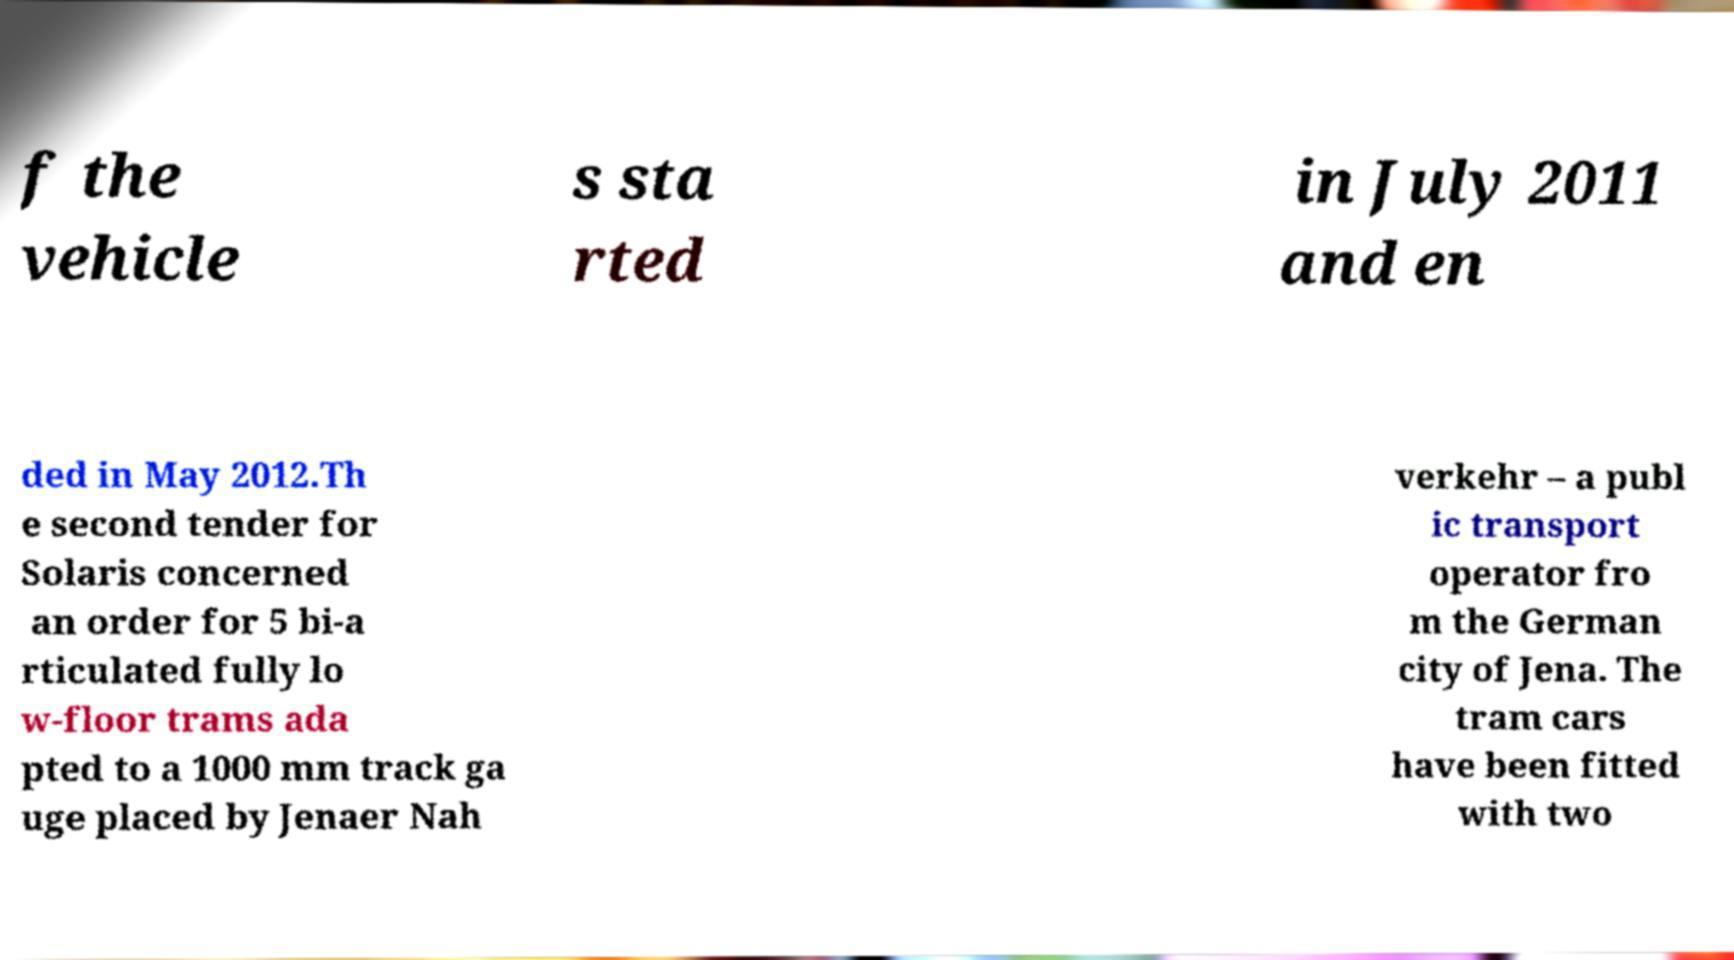There's text embedded in this image that I need extracted. Can you transcribe it verbatim? f the vehicle s sta rted in July 2011 and en ded in May 2012.Th e second tender for Solaris concerned an order for 5 bi-a rticulated fully lo w-floor trams ada pted to a 1000 mm track ga uge placed by Jenaer Nah verkehr – a publ ic transport operator fro m the German city of Jena. The tram cars have been fitted with two 